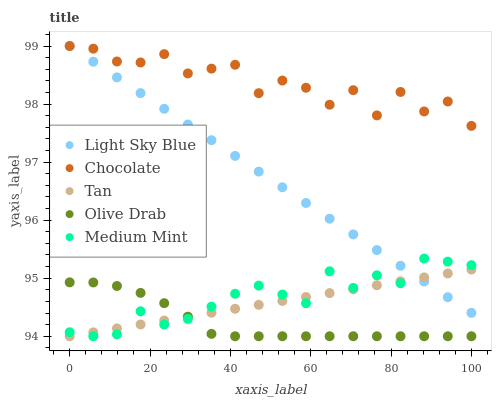Does Olive Drab have the minimum area under the curve?
Answer yes or no. Yes. Does Chocolate have the maximum area under the curve?
Answer yes or no. Yes. Does Tan have the minimum area under the curve?
Answer yes or no. No. Does Tan have the maximum area under the curve?
Answer yes or no. No. Is Tan the smoothest?
Answer yes or no. Yes. Is Chocolate the roughest?
Answer yes or no. Yes. Is Light Sky Blue the smoothest?
Answer yes or no. No. Is Light Sky Blue the roughest?
Answer yes or no. No. Does Medium Mint have the lowest value?
Answer yes or no. Yes. Does Light Sky Blue have the lowest value?
Answer yes or no. No. Does Chocolate have the highest value?
Answer yes or no. Yes. Does Tan have the highest value?
Answer yes or no. No. Is Medium Mint less than Chocolate?
Answer yes or no. Yes. Is Chocolate greater than Medium Mint?
Answer yes or no. Yes. Does Olive Drab intersect Medium Mint?
Answer yes or no. Yes. Is Olive Drab less than Medium Mint?
Answer yes or no. No. Is Olive Drab greater than Medium Mint?
Answer yes or no. No. Does Medium Mint intersect Chocolate?
Answer yes or no. No. 